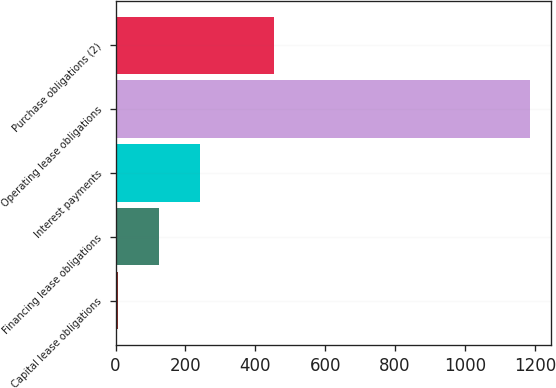Convert chart to OTSL. <chart><loc_0><loc_0><loc_500><loc_500><bar_chart><fcel>Capital lease obligations<fcel>Financing lease obligations<fcel>Interest payments<fcel>Operating lease obligations<fcel>Purchase obligations (2)<nl><fcel>6<fcel>124.1<fcel>242.2<fcel>1187<fcel>454<nl></chart> 